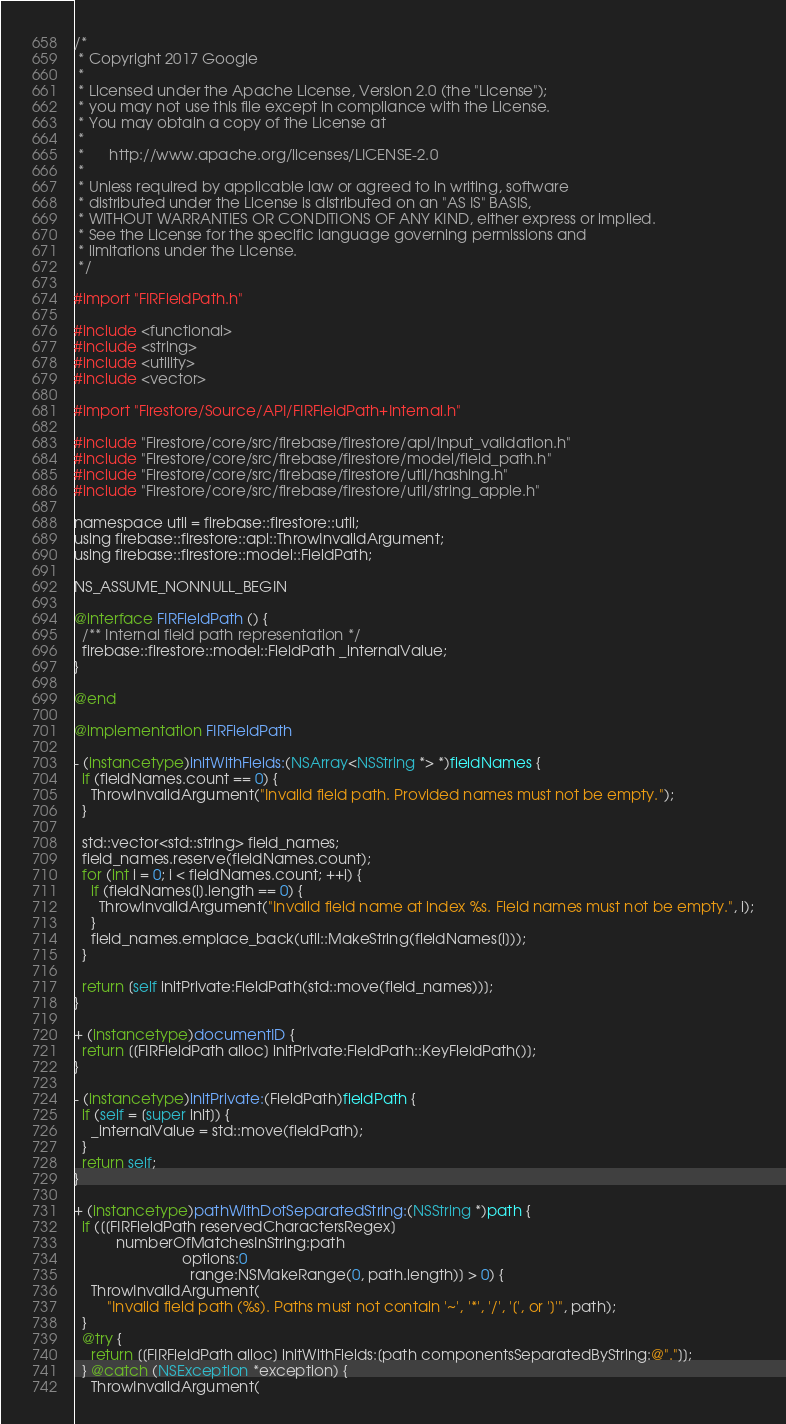Convert code to text. <code><loc_0><loc_0><loc_500><loc_500><_ObjectiveC_>/*
 * Copyright 2017 Google
 *
 * Licensed under the Apache License, Version 2.0 (the "License");
 * you may not use this file except in compliance with the License.
 * You may obtain a copy of the License at
 *
 *      http://www.apache.org/licenses/LICENSE-2.0
 *
 * Unless required by applicable law or agreed to in writing, software
 * distributed under the License is distributed on an "AS IS" BASIS,
 * WITHOUT WARRANTIES OR CONDITIONS OF ANY KIND, either express or implied.
 * See the License for the specific language governing permissions and
 * limitations under the License.
 */

#import "FIRFieldPath.h"

#include <functional>
#include <string>
#include <utility>
#include <vector>

#import "Firestore/Source/API/FIRFieldPath+Internal.h"

#include "Firestore/core/src/firebase/firestore/api/input_validation.h"
#include "Firestore/core/src/firebase/firestore/model/field_path.h"
#include "Firestore/core/src/firebase/firestore/util/hashing.h"
#include "Firestore/core/src/firebase/firestore/util/string_apple.h"

namespace util = firebase::firestore::util;
using firebase::firestore::api::ThrowInvalidArgument;
using firebase::firestore::model::FieldPath;

NS_ASSUME_NONNULL_BEGIN

@interface FIRFieldPath () {
  /** Internal field path representation */
  firebase::firestore::model::FieldPath _internalValue;
}

@end

@implementation FIRFieldPath

- (instancetype)initWithFields:(NSArray<NSString *> *)fieldNames {
  if (fieldNames.count == 0) {
    ThrowInvalidArgument("Invalid field path. Provided names must not be empty.");
  }

  std::vector<std::string> field_names;
  field_names.reserve(fieldNames.count);
  for (int i = 0; i < fieldNames.count; ++i) {
    if (fieldNames[i].length == 0) {
      ThrowInvalidArgument("Invalid field name at index %s. Field names must not be empty.", i);
    }
    field_names.emplace_back(util::MakeString(fieldNames[i]));
  }

  return [self initPrivate:FieldPath(std::move(field_names))];
}

+ (instancetype)documentID {
  return [[FIRFieldPath alloc] initPrivate:FieldPath::KeyFieldPath()];
}

- (instancetype)initPrivate:(FieldPath)fieldPath {
  if (self = [super init]) {
    _internalValue = std::move(fieldPath);
  }
  return self;
}

+ (instancetype)pathWithDotSeparatedString:(NSString *)path {
  if ([[FIRFieldPath reservedCharactersRegex]
          numberOfMatchesInString:path
                          options:0
                            range:NSMakeRange(0, path.length)] > 0) {
    ThrowInvalidArgument(
        "Invalid field path (%s). Paths must not contain '~', '*', '/', '[', or ']'", path);
  }
  @try {
    return [[FIRFieldPath alloc] initWithFields:[path componentsSeparatedByString:@"."]];
  } @catch (NSException *exception) {
    ThrowInvalidArgument(</code> 